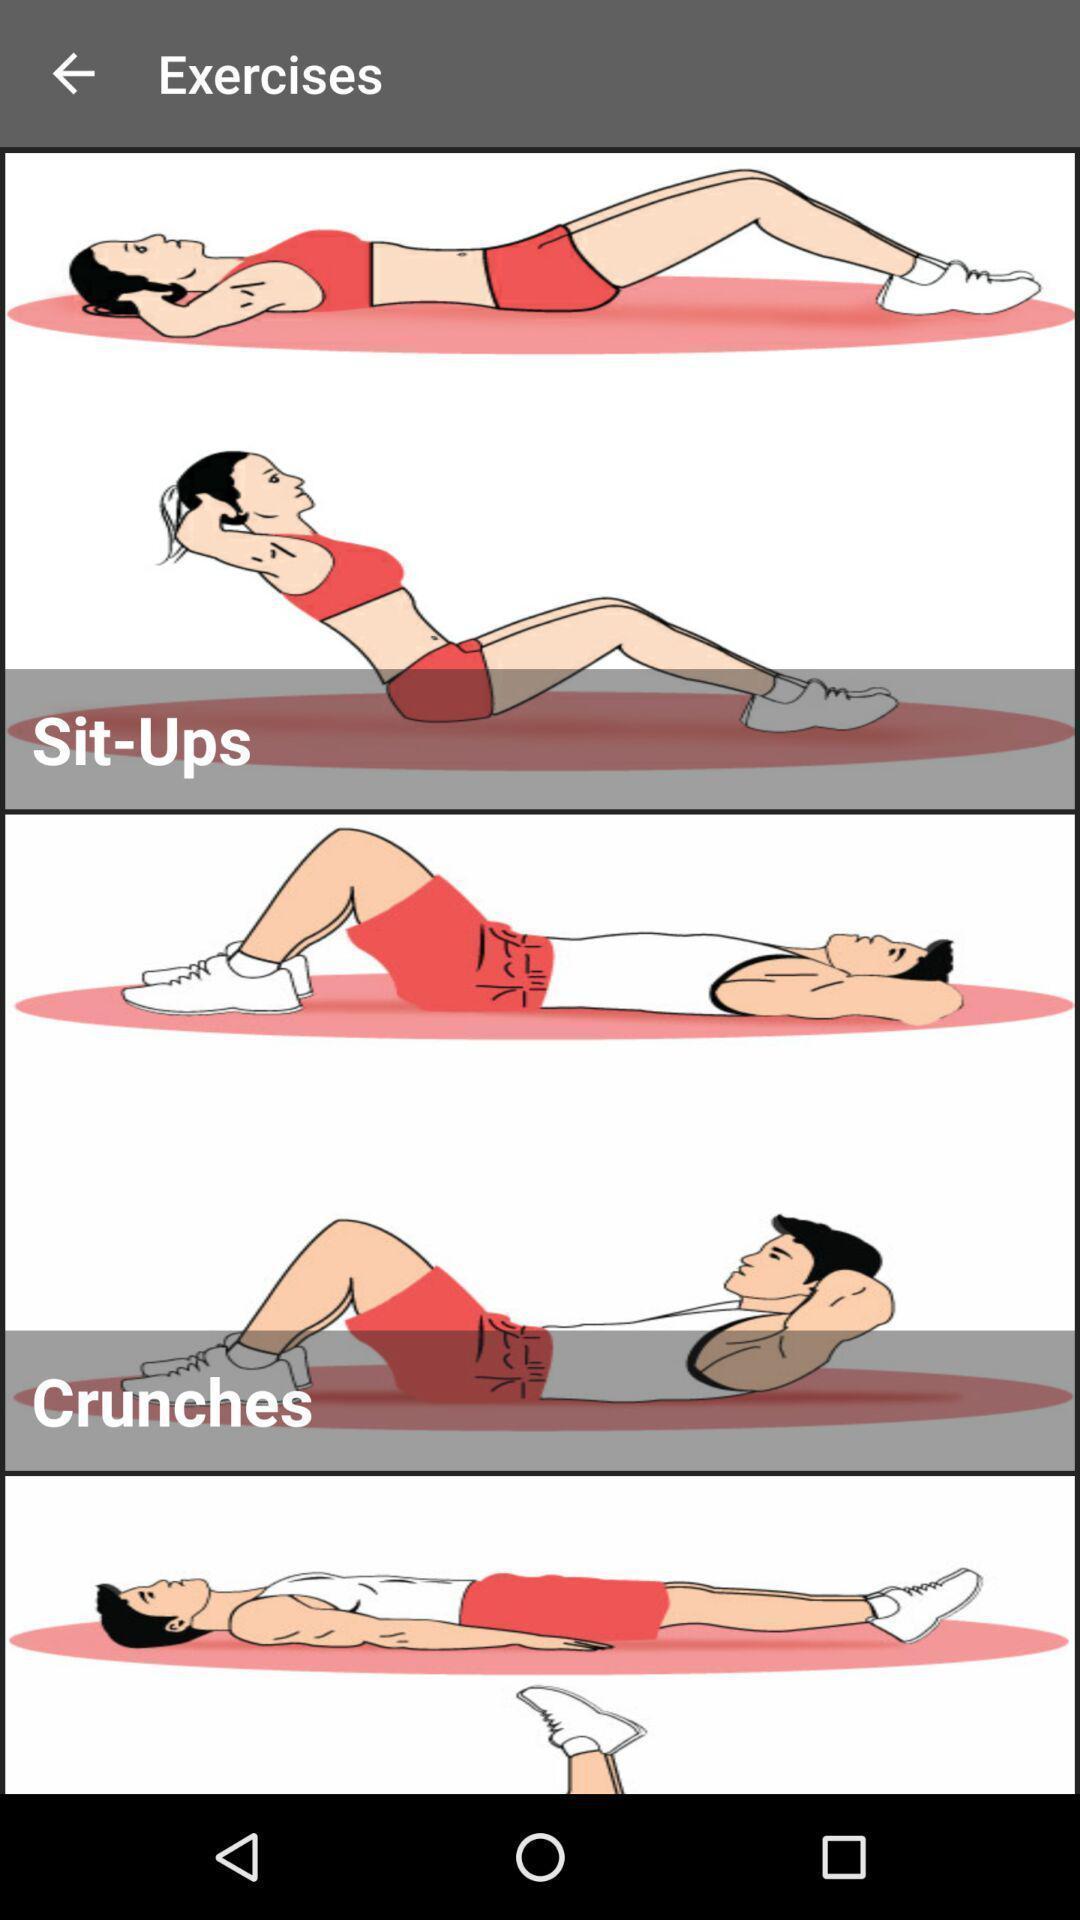Describe the key features of this screenshot. Screen displaying multiple workout images and names. 